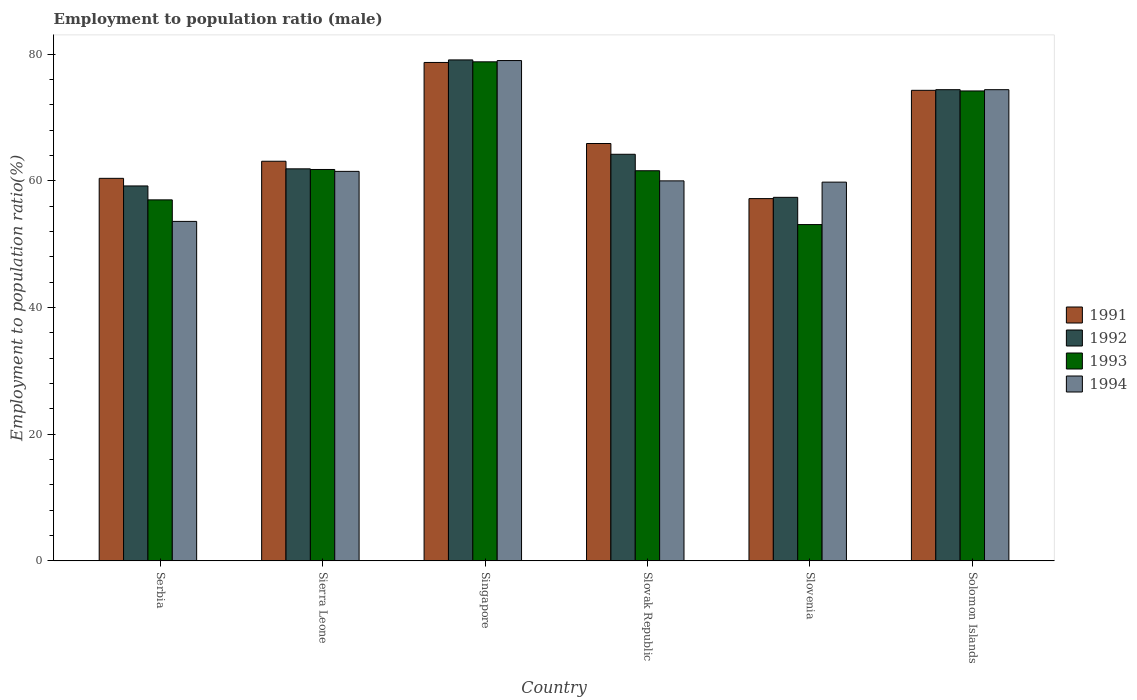Are the number of bars per tick equal to the number of legend labels?
Provide a succinct answer. Yes. Are the number of bars on each tick of the X-axis equal?
Your answer should be very brief. Yes. How many bars are there on the 5th tick from the left?
Keep it short and to the point. 4. What is the label of the 4th group of bars from the left?
Provide a short and direct response. Slovak Republic. In how many cases, is the number of bars for a given country not equal to the number of legend labels?
Your answer should be compact. 0. What is the employment to population ratio in 1992 in Serbia?
Provide a short and direct response. 59.2. Across all countries, what is the maximum employment to population ratio in 1992?
Offer a very short reply. 79.1. Across all countries, what is the minimum employment to population ratio in 1992?
Provide a short and direct response. 57.4. In which country was the employment to population ratio in 1994 maximum?
Your answer should be compact. Singapore. In which country was the employment to population ratio in 1993 minimum?
Ensure brevity in your answer.  Slovenia. What is the total employment to population ratio in 1992 in the graph?
Offer a terse response. 396.2. What is the difference between the employment to population ratio in 1993 in Slovenia and that in Solomon Islands?
Give a very brief answer. -21.1. What is the difference between the employment to population ratio in 1993 in Serbia and the employment to population ratio in 1992 in Slovak Republic?
Offer a very short reply. -7.2. What is the average employment to population ratio in 1991 per country?
Give a very brief answer. 66.6. What is the difference between the employment to population ratio of/in 1992 and employment to population ratio of/in 1991 in Slovenia?
Your answer should be very brief. 0.2. In how many countries, is the employment to population ratio in 1993 greater than 68 %?
Your response must be concise. 2. What is the ratio of the employment to population ratio in 1992 in Slovenia to that in Solomon Islands?
Keep it short and to the point. 0.77. Is the employment to population ratio in 1992 in Singapore less than that in Slovenia?
Offer a very short reply. No. Is the difference between the employment to population ratio in 1992 in Slovak Republic and Slovenia greater than the difference between the employment to population ratio in 1991 in Slovak Republic and Slovenia?
Give a very brief answer. No. What is the difference between the highest and the second highest employment to population ratio in 1992?
Your response must be concise. -10.2. What is the difference between the highest and the lowest employment to population ratio in 1992?
Offer a terse response. 21.7. Is it the case that in every country, the sum of the employment to population ratio in 1992 and employment to population ratio in 1993 is greater than the sum of employment to population ratio in 1991 and employment to population ratio in 1994?
Provide a short and direct response. No. Are all the bars in the graph horizontal?
Your answer should be compact. No. How many countries are there in the graph?
Give a very brief answer. 6. What is the difference between two consecutive major ticks on the Y-axis?
Give a very brief answer. 20. Does the graph contain any zero values?
Your answer should be compact. No. Does the graph contain grids?
Your response must be concise. No. What is the title of the graph?
Ensure brevity in your answer.  Employment to population ratio (male). Does "1962" appear as one of the legend labels in the graph?
Your answer should be compact. No. What is the label or title of the X-axis?
Provide a short and direct response. Country. What is the Employment to population ratio(%) of 1991 in Serbia?
Offer a terse response. 60.4. What is the Employment to population ratio(%) of 1992 in Serbia?
Give a very brief answer. 59.2. What is the Employment to population ratio(%) of 1993 in Serbia?
Provide a short and direct response. 57. What is the Employment to population ratio(%) of 1994 in Serbia?
Provide a short and direct response. 53.6. What is the Employment to population ratio(%) of 1991 in Sierra Leone?
Offer a very short reply. 63.1. What is the Employment to population ratio(%) in 1992 in Sierra Leone?
Give a very brief answer. 61.9. What is the Employment to population ratio(%) in 1993 in Sierra Leone?
Provide a short and direct response. 61.8. What is the Employment to population ratio(%) in 1994 in Sierra Leone?
Your response must be concise. 61.5. What is the Employment to population ratio(%) of 1991 in Singapore?
Your answer should be very brief. 78.7. What is the Employment to population ratio(%) of 1992 in Singapore?
Your answer should be very brief. 79.1. What is the Employment to population ratio(%) of 1993 in Singapore?
Keep it short and to the point. 78.8. What is the Employment to population ratio(%) of 1994 in Singapore?
Keep it short and to the point. 79. What is the Employment to population ratio(%) of 1991 in Slovak Republic?
Offer a very short reply. 65.9. What is the Employment to population ratio(%) of 1992 in Slovak Republic?
Give a very brief answer. 64.2. What is the Employment to population ratio(%) of 1993 in Slovak Republic?
Your response must be concise. 61.6. What is the Employment to population ratio(%) in 1994 in Slovak Republic?
Offer a terse response. 60. What is the Employment to population ratio(%) of 1991 in Slovenia?
Make the answer very short. 57.2. What is the Employment to population ratio(%) of 1992 in Slovenia?
Provide a short and direct response. 57.4. What is the Employment to population ratio(%) of 1993 in Slovenia?
Provide a succinct answer. 53.1. What is the Employment to population ratio(%) in 1994 in Slovenia?
Provide a short and direct response. 59.8. What is the Employment to population ratio(%) in 1991 in Solomon Islands?
Your response must be concise. 74.3. What is the Employment to population ratio(%) of 1992 in Solomon Islands?
Provide a short and direct response. 74.4. What is the Employment to population ratio(%) in 1993 in Solomon Islands?
Keep it short and to the point. 74.2. What is the Employment to population ratio(%) of 1994 in Solomon Islands?
Your response must be concise. 74.4. Across all countries, what is the maximum Employment to population ratio(%) of 1991?
Give a very brief answer. 78.7. Across all countries, what is the maximum Employment to population ratio(%) of 1992?
Provide a succinct answer. 79.1. Across all countries, what is the maximum Employment to population ratio(%) in 1993?
Your response must be concise. 78.8. Across all countries, what is the maximum Employment to population ratio(%) in 1994?
Your response must be concise. 79. Across all countries, what is the minimum Employment to population ratio(%) of 1991?
Your response must be concise. 57.2. Across all countries, what is the minimum Employment to population ratio(%) of 1992?
Your answer should be very brief. 57.4. Across all countries, what is the minimum Employment to population ratio(%) in 1993?
Your answer should be compact. 53.1. Across all countries, what is the minimum Employment to population ratio(%) in 1994?
Your response must be concise. 53.6. What is the total Employment to population ratio(%) in 1991 in the graph?
Provide a short and direct response. 399.6. What is the total Employment to population ratio(%) in 1992 in the graph?
Offer a terse response. 396.2. What is the total Employment to population ratio(%) in 1993 in the graph?
Ensure brevity in your answer.  386.5. What is the total Employment to population ratio(%) in 1994 in the graph?
Ensure brevity in your answer.  388.3. What is the difference between the Employment to population ratio(%) in 1991 in Serbia and that in Sierra Leone?
Offer a very short reply. -2.7. What is the difference between the Employment to population ratio(%) in 1993 in Serbia and that in Sierra Leone?
Your response must be concise. -4.8. What is the difference between the Employment to population ratio(%) in 1991 in Serbia and that in Singapore?
Give a very brief answer. -18.3. What is the difference between the Employment to population ratio(%) in 1992 in Serbia and that in Singapore?
Make the answer very short. -19.9. What is the difference between the Employment to population ratio(%) in 1993 in Serbia and that in Singapore?
Offer a terse response. -21.8. What is the difference between the Employment to population ratio(%) of 1994 in Serbia and that in Singapore?
Your answer should be compact. -25.4. What is the difference between the Employment to population ratio(%) in 1992 in Serbia and that in Slovenia?
Your answer should be very brief. 1.8. What is the difference between the Employment to population ratio(%) in 1994 in Serbia and that in Slovenia?
Your answer should be compact. -6.2. What is the difference between the Employment to population ratio(%) of 1992 in Serbia and that in Solomon Islands?
Your answer should be very brief. -15.2. What is the difference between the Employment to population ratio(%) of 1993 in Serbia and that in Solomon Islands?
Make the answer very short. -17.2. What is the difference between the Employment to population ratio(%) of 1994 in Serbia and that in Solomon Islands?
Your answer should be compact. -20.8. What is the difference between the Employment to population ratio(%) in 1991 in Sierra Leone and that in Singapore?
Your response must be concise. -15.6. What is the difference between the Employment to population ratio(%) in 1992 in Sierra Leone and that in Singapore?
Keep it short and to the point. -17.2. What is the difference between the Employment to population ratio(%) in 1993 in Sierra Leone and that in Singapore?
Your answer should be very brief. -17. What is the difference between the Employment to population ratio(%) in 1994 in Sierra Leone and that in Singapore?
Provide a short and direct response. -17.5. What is the difference between the Employment to population ratio(%) in 1992 in Sierra Leone and that in Slovak Republic?
Offer a very short reply. -2.3. What is the difference between the Employment to population ratio(%) in 1994 in Sierra Leone and that in Slovak Republic?
Make the answer very short. 1.5. What is the difference between the Employment to population ratio(%) in 1991 in Sierra Leone and that in Slovenia?
Provide a succinct answer. 5.9. What is the difference between the Employment to population ratio(%) of 1992 in Sierra Leone and that in Slovenia?
Make the answer very short. 4.5. What is the difference between the Employment to population ratio(%) in 1994 in Sierra Leone and that in Slovenia?
Give a very brief answer. 1.7. What is the difference between the Employment to population ratio(%) of 1993 in Sierra Leone and that in Solomon Islands?
Provide a short and direct response. -12.4. What is the difference between the Employment to population ratio(%) of 1994 in Sierra Leone and that in Solomon Islands?
Offer a very short reply. -12.9. What is the difference between the Employment to population ratio(%) in 1993 in Singapore and that in Slovak Republic?
Offer a terse response. 17.2. What is the difference between the Employment to population ratio(%) of 1991 in Singapore and that in Slovenia?
Make the answer very short. 21.5. What is the difference between the Employment to population ratio(%) in 1992 in Singapore and that in Slovenia?
Provide a succinct answer. 21.7. What is the difference between the Employment to population ratio(%) of 1993 in Singapore and that in Slovenia?
Your answer should be compact. 25.7. What is the difference between the Employment to population ratio(%) in 1994 in Singapore and that in Solomon Islands?
Provide a short and direct response. 4.6. What is the difference between the Employment to population ratio(%) of 1992 in Slovak Republic and that in Slovenia?
Make the answer very short. 6.8. What is the difference between the Employment to population ratio(%) of 1991 in Slovak Republic and that in Solomon Islands?
Keep it short and to the point. -8.4. What is the difference between the Employment to population ratio(%) of 1993 in Slovak Republic and that in Solomon Islands?
Provide a short and direct response. -12.6. What is the difference between the Employment to population ratio(%) in 1994 in Slovak Republic and that in Solomon Islands?
Your answer should be compact. -14.4. What is the difference between the Employment to population ratio(%) in 1991 in Slovenia and that in Solomon Islands?
Keep it short and to the point. -17.1. What is the difference between the Employment to population ratio(%) of 1992 in Slovenia and that in Solomon Islands?
Give a very brief answer. -17. What is the difference between the Employment to population ratio(%) in 1993 in Slovenia and that in Solomon Islands?
Provide a short and direct response. -21.1. What is the difference between the Employment to population ratio(%) in 1994 in Slovenia and that in Solomon Islands?
Keep it short and to the point. -14.6. What is the difference between the Employment to population ratio(%) of 1991 in Serbia and the Employment to population ratio(%) of 1992 in Sierra Leone?
Offer a terse response. -1.5. What is the difference between the Employment to population ratio(%) in 1992 in Serbia and the Employment to population ratio(%) in 1993 in Sierra Leone?
Make the answer very short. -2.6. What is the difference between the Employment to population ratio(%) of 1991 in Serbia and the Employment to population ratio(%) of 1992 in Singapore?
Ensure brevity in your answer.  -18.7. What is the difference between the Employment to population ratio(%) of 1991 in Serbia and the Employment to population ratio(%) of 1993 in Singapore?
Your response must be concise. -18.4. What is the difference between the Employment to population ratio(%) of 1991 in Serbia and the Employment to population ratio(%) of 1994 in Singapore?
Ensure brevity in your answer.  -18.6. What is the difference between the Employment to population ratio(%) of 1992 in Serbia and the Employment to population ratio(%) of 1993 in Singapore?
Ensure brevity in your answer.  -19.6. What is the difference between the Employment to population ratio(%) of 1992 in Serbia and the Employment to population ratio(%) of 1994 in Singapore?
Give a very brief answer. -19.8. What is the difference between the Employment to population ratio(%) of 1993 in Serbia and the Employment to population ratio(%) of 1994 in Singapore?
Keep it short and to the point. -22. What is the difference between the Employment to population ratio(%) of 1991 in Serbia and the Employment to population ratio(%) of 1992 in Slovak Republic?
Keep it short and to the point. -3.8. What is the difference between the Employment to population ratio(%) in 1991 in Serbia and the Employment to population ratio(%) in 1994 in Slovak Republic?
Ensure brevity in your answer.  0.4. What is the difference between the Employment to population ratio(%) in 1991 in Serbia and the Employment to population ratio(%) in 1992 in Slovenia?
Provide a short and direct response. 3. What is the difference between the Employment to population ratio(%) in 1991 in Serbia and the Employment to population ratio(%) in 1994 in Slovenia?
Make the answer very short. 0.6. What is the difference between the Employment to population ratio(%) in 1992 in Serbia and the Employment to population ratio(%) in 1993 in Slovenia?
Offer a terse response. 6.1. What is the difference between the Employment to population ratio(%) of 1992 in Serbia and the Employment to population ratio(%) of 1994 in Slovenia?
Ensure brevity in your answer.  -0.6. What is the difference between the Employment to population ratio(%) of 1991 in Serbia and the Employment to population ratio(%) of 1993 in Solomon Islands?
Your answer should be compact. -13.8. What is the difference between the Employment to population ratio(%) of 1991 in Serbia and the Employment to population ratio(%) of 1994 in Solomon Islands?
Offer a terse response. -14. What is the difference between the Employment to population ratio(%) in 1992 in Serbia and the Employment to population ratio(%) in 1994 in Solomon Islands?
Your answer should be very brief. -15.2. What is the difference between the Employment to population ratio(%) of 1993 in Serbia and the Employment to population ratio(%) of 1994 in Solomon Islands?
Provide a short and direct response. -17.4. What is the difference between the Employment to population ratio(%) in 1991 in Sierra Leone and the Employment to population ratio(%) in 1993 in Singapore?
Keep it short and to the point. -15.7. What is the difference between the Employment to population ratio(%) in 1991 in Sierra Leone and the Employment to population ratio(%) in 1994 in Singapore?
Your response must be concise. -15.9. What is the difference between the Employment to population ratio(%) in 1992 in Sierra Leone and the Employment to population ratio(%) in 1993 in Singapore?
Your answer should be compact. -16.9. What is the difference between the Employment to population ratio(%) of 1992 in Sierra Leone and the Employment to population ratio(%) of 1994 in Singapore?
Provide a short and direct response. -17.1. What is the difference between the Employment to population ratio(%) of 1993 in Sierra Leone and the Employment to population ratio(%) of 1994 in Singapore?
Offer a terse response. -17.2. What is the difference between the Employment to population ratio(%) in 1991 in Sierra Leone and the Employment to population ratio(%) in 1994 in Slovak Republic?
Offer a very short reply. 3.1. What is the difference between the Employment to population ratio(%) of 1992 in Sierra Leone and the Employment to population ratio(%) of 1993 in Slovak Republic?
Your answer should be very brief. 0.3. What is the difference between the Employment to population ratio(%) in 1992 in Sierra Leone and the Employment to population ratio(%) in 1994 in Slovak Republic?
Give a very brief answer. 1.9. What is the difference between the Employment to population ratio(%) of 1993 in Sierra Leone and the Employment to population ratio(%) of 1994 in Slovak Republic?
Your response must be concise. 1.8. What is the difference between the Employment to population ratio(%) in 1991 in Sierra Leone and the Employment to population ratio(%) in 1992 in Slovenia?
Give a very brief answer. 5.7. What is the difference between the Employment to population ratio(%) in 1992 in Sierra Leone and the Employment to population ratio(%) in 1993 in Slovenia?
Offer a terse response. 8.8. What is the difference between the Employment to population ratio(%) of 1993 in Sierra Leone and the Employment to population ratio(%) of 1994 in Slovenia?
Offer a terse response. 2. What is the difference between the Employment to population ratio(%) in 1991 in Sierra Leone and the Employment to population ratio(%) in 1993 in Solomon Islands?
Your answer should be very brief. -11.1. What is the difference between the Employment to population ratio(%) in 1991 in Sierra Leone and the Employment to population ratio(%) in 1994 in Solomon Islands?
Your answer should be compact. -11.3. What is the difference between the Employment to population ratio(%) of 1992 in Sierra Leone and the Employment to population ratio(%) of 1993 in Solomon Islands?
Your response must be concise. -12.3. What is the difference between the Employment to population ratio(%) in 1992 in Sierra Leone and the Employment to population ratio(%) in 1994 in Solomon Islands?
Give a very brief answer. -12.5. What is the difference between the Employment to population ratio(%) in 1991 in Singapore and the Employment to population ratio(%) in 1993 in Slovak Republic?
Provide a succinct answer. 17.1. What is the difference between the Employment to population ratio(%) of 1992 in Singapore and the Employment to population ratio(%) of 1994 in Slovak Republic?
Keep it short and to the point. 19.1. What is the difference between the Employment to population ratio(%) of 1991 in Singapore and the Employment to population ratio(%) of 1992 in Slovenia?
Ensure brevity in your answer.  21.3. What is the difference between the Employment to population ratio(%) in 1991 in Singapore and the Employment to population ratio(%) in 1993 in Slovenia?
Offer a very short reply. 25.6. What is the difference between the Employment to population ratio(%) in 1992 in Singapore and the Employment to population ratio(%) in 1993 in Slovenia?
Make the answer very short. 26. What is the difference between the Employment to population ratio(%) in 1992 in Singapore and the Employment to population ratio(%) in 1994 in Slovenia?
Offer a terse response. 19.3. What is the difference between the Employment to population ratio(%) of 1993 in Singapore and the Employment to population ratio(%) of 1994 in Slovenia?
Offer a terse response. 19. What is the difference between the Employment to population ratio(%) of 1991 in Singapore and the Employment to population ratio(%) of 1992 in Solomon Islands?
Your answer should be compact. 4.3. What is the difference between the Employment to population ratio(%) of 1992 in Singapore and the Employment to population ratio(%) of 1993 in Solomon Islands?
Offer a terse response. 4.9. What is the difference between the Employment to population ratio(%) in 1992 in Singapore and the Employment to population ratio(%) in 1994 in Solomon Islands?
Your answer should be very brief. 4.7. What is the difference between the Employment to population ratio(%) of 1991 in Slovak Republic and the Employment to population ratio(%) of 1992 in Slovenia?
Keep it short and to the point. 8.5. What is the difference between the Employment to population ratio(%) of 1991 in Slovak Republic and the Employment to population ratio(%) of 1993 in Slovenia?
Provide a succinct answer. 12.8. What is the difference between the Employment to population ratio(%) of 1991 in Slovak Republic and the Employment to population ratio(%) of 1994 in Slovenia?
Offer a very short reply. 6.1. What is the difference between the Employment to population ratio(%) in 1992 in Slovak Republic and the Employment to population ratio(%) in 1993 in Slovenia?
Your answer should be compact. 11.1. What is the difference between the Employment to population ratio(%) of 1993 in Slovak Republic and the Employment to population ratio(%) of 1994 in Solomon Islands?
Provide a succinct answer. -12.8. What is the difference between the Employment to population ratio(%) of 1991 in Slovenia and the Employment to population ratio(%) of 1992 in Solomon Islands?
Provide a short and direct response. -17.2. What is the difference between the Employment to population ratio(%) in 1991 in Slovenia and the Employment to population ratio(%) in 1994 in Solomon Islands?
Offer a terse response. -17.2. What is the difference between the Employment to population ratio(%) in 1992 in Slovenia and the Employment to population ratio(%) in 1993 in Solomon Islands?
Keep it short and to the point. -16.8. What is the difference between the Employment to population ratio(%) of 1992 in Slovenia and the Employment to population ratio(%) of 1994 in Solomon Islands?
Give a very brief answer. -17. What is the difference between the Employment to population ratio(%) in 1993 in Slovenia and the Employment to population ratio(%) in 1994 in Solomon Islands?
Offer a very short reply. -21.3. What is the average Employment to population ratio(%) in 1991 per country?
Offer a terse response. 66.6. What is the average Employment to population ratio(%) of 1992 per country?
Make the answer very short. 66.03. What is the average Employment to population ratio(%) in 1993 per country?
Ensure brevity in your answer.  64.42. What is the average Employment to population ratio(%) in 1994 per country?
Keep it short and to the point. 64.72. What is the difference between the Employment to population ratio(%) in 1993 and Employment to population ratio(%) in 1994 in Serbia?
Provide a succinct answer. 3.4. What is the difference between the Employment to population ratio(%) in 1992 and Employment to population ratio(%) in 1994 in Sierra Leone?
Provide a succinct answer. 0.4. What is the difference between the Employment to population ratio(%) in 1992 and Employment to population ratio(%) in 1993 in Singapore?
Ensure brevity in your answer.  0.3. What is the difference between the Employment to population ratio(%) of 1993 and Employment to population ratio(%) of 1994 in Singapore?
Provide a succinct answer. -0.2. What is the difference between the Employment to population ratio(%) of 1991 and Employment to population ratio(%) of 1994 in Slovak Republic?
Offer a very short reply. 5.9. What is the difference between the Employment to population ratio(%) of 1992 and Employment to population ratio(%) of 1994 in Slovak Republic?
Offer a terse response. 4.2. What is the difference between the Employment to population ratio(%) in 1993 and Employment to population ratio(%) in 1994 in Slovak Republic?
Make the answer very short. 1.6. What is the difference between the Employment to population ratio(%) of 1991 and Employment to population ratio(%) of 1992 in Slovenia?
Provide a succinct answer. -0.2. What is the difference between the Employment to population ratio(%) in 1991 and Employment to population ratio(%) in 1993 in Slovenia?
Your answer should be very brief. 4.1. What is the difference between the Employment to population ratio(%) of 1991 and Employment to population ratio(%) of 1994 in Slovenia?
Your answer should be very brief. -2.6. What is the difference between the Employment to population ratio(%) of 1992 and Employment to population ratio(%) of 1993 in Slovenia?
Your answer should be very brief. 4.3. What is the difference between the Employment to population ratio(%) of 1992 and Employment to population ratio(%) of 1994 in Slovenia?
Your answer should be very brief. -2.4. What is the difference between the Employment to population ratio(%) in 1993 and Employment to population ratio(%) in 1994 in Slovenia?
Give a very brief answer. -6.7. What is the difference between the Employment to population ratio(%) of 1992 and Employment to population ratio(%) of 1993 in Solomon Islands?
Provide a succinct answer. 0.2. What is the ratio of the Employment to population ratio(%) of 1991 in Serbia to that in Sierra Leone?
Ensure brevity in your answer.  0.96. What is the ratio of the Employment to population ratio(%) in 1992 in Serbia to that in Sierra Leone?
Your response must be concise. 0.96. What is the ratio of the Employment to population ratio(%) in 1993 in Serbia to that in Sierra Leone?
Keep it short and to the point. 0.92. What is the ratio of the Employment to population ratio(%) of 1994 in Serbia to that in Sierra Leone?
Offer a terse response. 0.87. What is the ratio of the Employment to population ratio(%) in 1991 in Serbia to that in Singapore?
Offer a terse response. 0.77. What is the ratio of the Employment to population ratio(%) in 1992 in Serbia to that in Singapore?
Your response must be concise. 0.75. What is the ratio of the Employment to population ratio(%) in 1993 in Serbia to that in Singapore?
Ensure brevity in your answer.  0.72. What is the ratio of the Employment to population ratio(%) of 1994 in Serbia to that in Singapore?
Offer a very short reply. 0.68. What is the ratio of the Employment to population ratio(%) in 1991 in Serbia to that in Slovak Republic?
Offer a terse response. 0.92. What is the ratio of the Employment to population ratio(%) of 1992 in Serbia to that in Slovak Republic?
Ensure brevity in your answer.  0.92. What is the ratio of the Employment to population ratio(%) in 1993 in Serbia to that in Slovak Republic?
Provide a short and direct response. 0.93. What is the ratio of the Employment to population ratio(%) of 1994 in Serbia to that in Slovak Republic?
Provide a short and direct response. 0.89. What is the ratio of the Employment to population ratio(%) of 1991 in Serbia to that in Slovenia?
Provide a succinct answer. 1.06. What is the ratio of the Employment to population ratio(%) in 1992 in Serbia to that in Slovenia?
Ensure brevity in your answer.  1.03. What is the ratio of the Employment to population ratio(%) in 1993 in Serbia to that in Slovenia?
Make the answer very short. 1.07. What is the ratio of the Employment to population ratio(%) of 1994 in Serbia to that in Slovenia?
Keep it short and to the point. 0.9. What is the ratio of the Employment to population ratio(%) in 1991 in Serbia to that in Solomon Islands?
Ensure brevity in your answer.  0.81. What is the ratio of the Employment to population ratio(%) in 1992 in Serbia to that in Solomon Islands?
Provide a succinct answer. 0.8. What is the ratio of the Employment to population ratio(%) of 1993 in Serbia to that in Solomon Islands?
Ensure brevity in your answer.  0.77. What is the ratio of the Employment to population ratio(%) in 1994 in Serbia to that in Solomon Islands?
Provide a succinct answer. 0.72. What is the ratio of the Employment to population ratio(%) in 1991 in Sierra Leone to that in Singapore?
Give a very brief answer. 0.8. What is the ratio of the Employment to population ratio(%) of 1992 in Sierra Leone to that in Singapore?
Offer a very short reply. 0.78. What is the ratio of the Employment to population ratio(%) of 1993 in Sierra Leone to that in Singapore?
Offer a very short reply. 0.78. What is the ratio of the Employment to population ratio(%) of 1994 in Sierra Leone to that in Singapore?
Ensure brevity in your answer.  0.78. What is the ratio of the Employment to population ratio(%) in 1991 in Sierra Leone to that in Slovak Republic?
Your answer should be compact. 0.96. What is the ratio of the Employment to population ratio(%) in 1992 in Sierra Leone to that in Slovak Republic?
Give a very brief answer. 0.96. What is the ratio of the Employment to population ratio(%) in 1993 in Sierra Leone to that in Slovak Republic?
Make the answer very short. 1. What is the ratio of the Employment to population ratio(%) of 1994 in Sierra Leone to that in Slovak Republic?
Make the answer very short. 1.02. What is the ratio of the Employment to population ratio(%) of 1991 in Sierra Leone to that in Slovenia?
Offer a terse response. 1.1. What is the ratio of the Employment to population ratio(%) in 1992 in Sierra Leone to that in Slovenia?
Ensure brevity in your answer.  1.08. What is the ratio of the Employment to population ratio(%) of 1993 in Sierra Leone to that in Slovenia?
Make the answer very short. 1.16. What is the ratio of the Employment to population ratio(%) of 1994 in Sierra Leone to that in Slovenia?
Keep it short and to the point. 1.03. What is the ratio of the Employment to population ratio(%) of 1991 in Sierra Leone to that in Solomon Islands?
Make the answer very short. 0.85. What is the ratio of the Employment to population ratio(%) in 1992 in Sierra Leone to that in Solomon Islands?
Keep it short and to the point. 0.83. What is the ratio of the Employment to population ratio(%) of 1993 in Sierra Leone to that in Solomon Islands?
Keep it short and to the point. 0.83. What is the ratio of the Employment to population ratio(%) in 1994 in Sierra Leone to that in Solomon Islands?
Your response must be concise. 0.83. What is the ratio of the Employment to population ratio(%) of 1991 in Singapore to that in Slovak Republic?
Make the answer very short. 1.19. What is the ratio of the Employment to population ratio(%) in 1992 in Singapore to that in Slovak Republic?
Offer a very short reply. 1.23. What is the ratio of the Employment to population ratio(%) in 1993 in Singapore to that in Slovak Republic?
Your answer should be very brief. 1.28. What is the ratio of the Employment to population ratio(%) of 1994 in Singapore to that in Slovak Republic?
Provide a succinct answer. 1.32. What is the ratio of the Employment to population ratio(%) in 1991 in Singapore to that in Slovenia?
Your answer should be very brief. 1.38. What is the ratio of the Employment to population ratio(%) of 1992 in Singapore to that in Slovenia?
Your answer should be very brief. 1.38. What is the ratio of the Employment to population ratio(%) in 1993 in Singapore to that in Slovenia?
Your answer should be very brief. 1.48. What is the ratio of the Employment to population ratio(%) in 1994 in Singapore to that in Slovenia?
Your answer should be very brief. 1.32. What is the ratio of the Employment to population ratio(%) in 1991 in Singapore to that in Solomon Islands?
Provide a short and direct response. 1.06. What is the ratio of the Employment to population ratio(%) of 1992 in Singapore to that in Solomon Islands?
Ensure brevity in your answer.  1.06. What is the ratio of the Employment to population ratio(%) of 1993 in Singapore to that in Solomon Islands?
Your answer should be very brief. 1.06. What is the ratio of the Employment to population ratio(%) in 1994 in Singapore to that in Solomon Islands?
Your answer should be compact. 1.06. What is the ratio of the Employment to population ratio(%) in 1991 in Slovak Republic to that in Slovenia?
Offer a very short reply. 1.15. What is the ratio of the Employment to population ratio(%) of 1992 in Slovak Republic to that in Slovenia?
Offer a very short reply. 1.12. What is the ratio of the Employment to population ratio(%) of 1993 in Slovak Republic to that in Slovenia?
Provide a short and direct response. 1.16. What is the ratio of the Employment to population ratio(%) in 1994 in Slovak Republic to that in Slovenia?
Ensure brevity in your answer.  1. What is the ratio of the Employment to population ratio(%) in 1991 in Slovak Republic to that in Solomon Islands?
Provide a succinct answer. 0.89. What is the ratio of the Employment to population ratio(%) in 1992 in Slovak Republic to that in Solomon Islands?
Offer a terse response. 0.86. What is the ratio of the Employment to population ratio(%) in 1993 in Slovak Republic to that in Solomon Islands?
Your answer should be very brief. 0.83. What is the ratio of the Employment to population ratio(%) of 1994 in Slovak Republic to that in Solomon Islands?
Make the answer very short. 0.81. What is the ratio of the Employment to population ratio(%) in 1991 in Slovenia to that in Solomon Islands?
Provide a succinct answer. 0.77. What is the ratio of the Employment to population ratio(%) in 1992 in Slovenia to that in Solomon Islands?
Make the answer very short. 0.77. What is the ratio of the Employment to population ratio(%) of 1993 in Slovenia to that in Solomon Islands?
Your response must be concise. 0.72. What is the ratio of the Employment to population ratio(%) in 1994 in Slovenia to that in Solomon Islands?
Your answer should be very brief. 0.8. What is the difference between the highest and the second highest Employment to population ratio(%) in 1991?
Your response must be concise. 4.4. What is the difference between the highest and the second highest Employment to population ratio(%) of 1992?
Provide a succinct answer. 4.7. What is the difference between the highest and the lowest Employment to population ratio(%) of 1991?
Your answer should be very brief. 21.5. What is the difference between the highest and the lowest Employment to population ratio(%) in 1992?
Ensure brevity in your answer.  21.7. What is the difference between the highest and the lowest Employment to population ratio(%) of 1993?
Make the answer very short. 25.7. What is the difference between the highest and the lowest Employment to population ratio(%) of 1994?
Give a very brief answer. 25.4. 